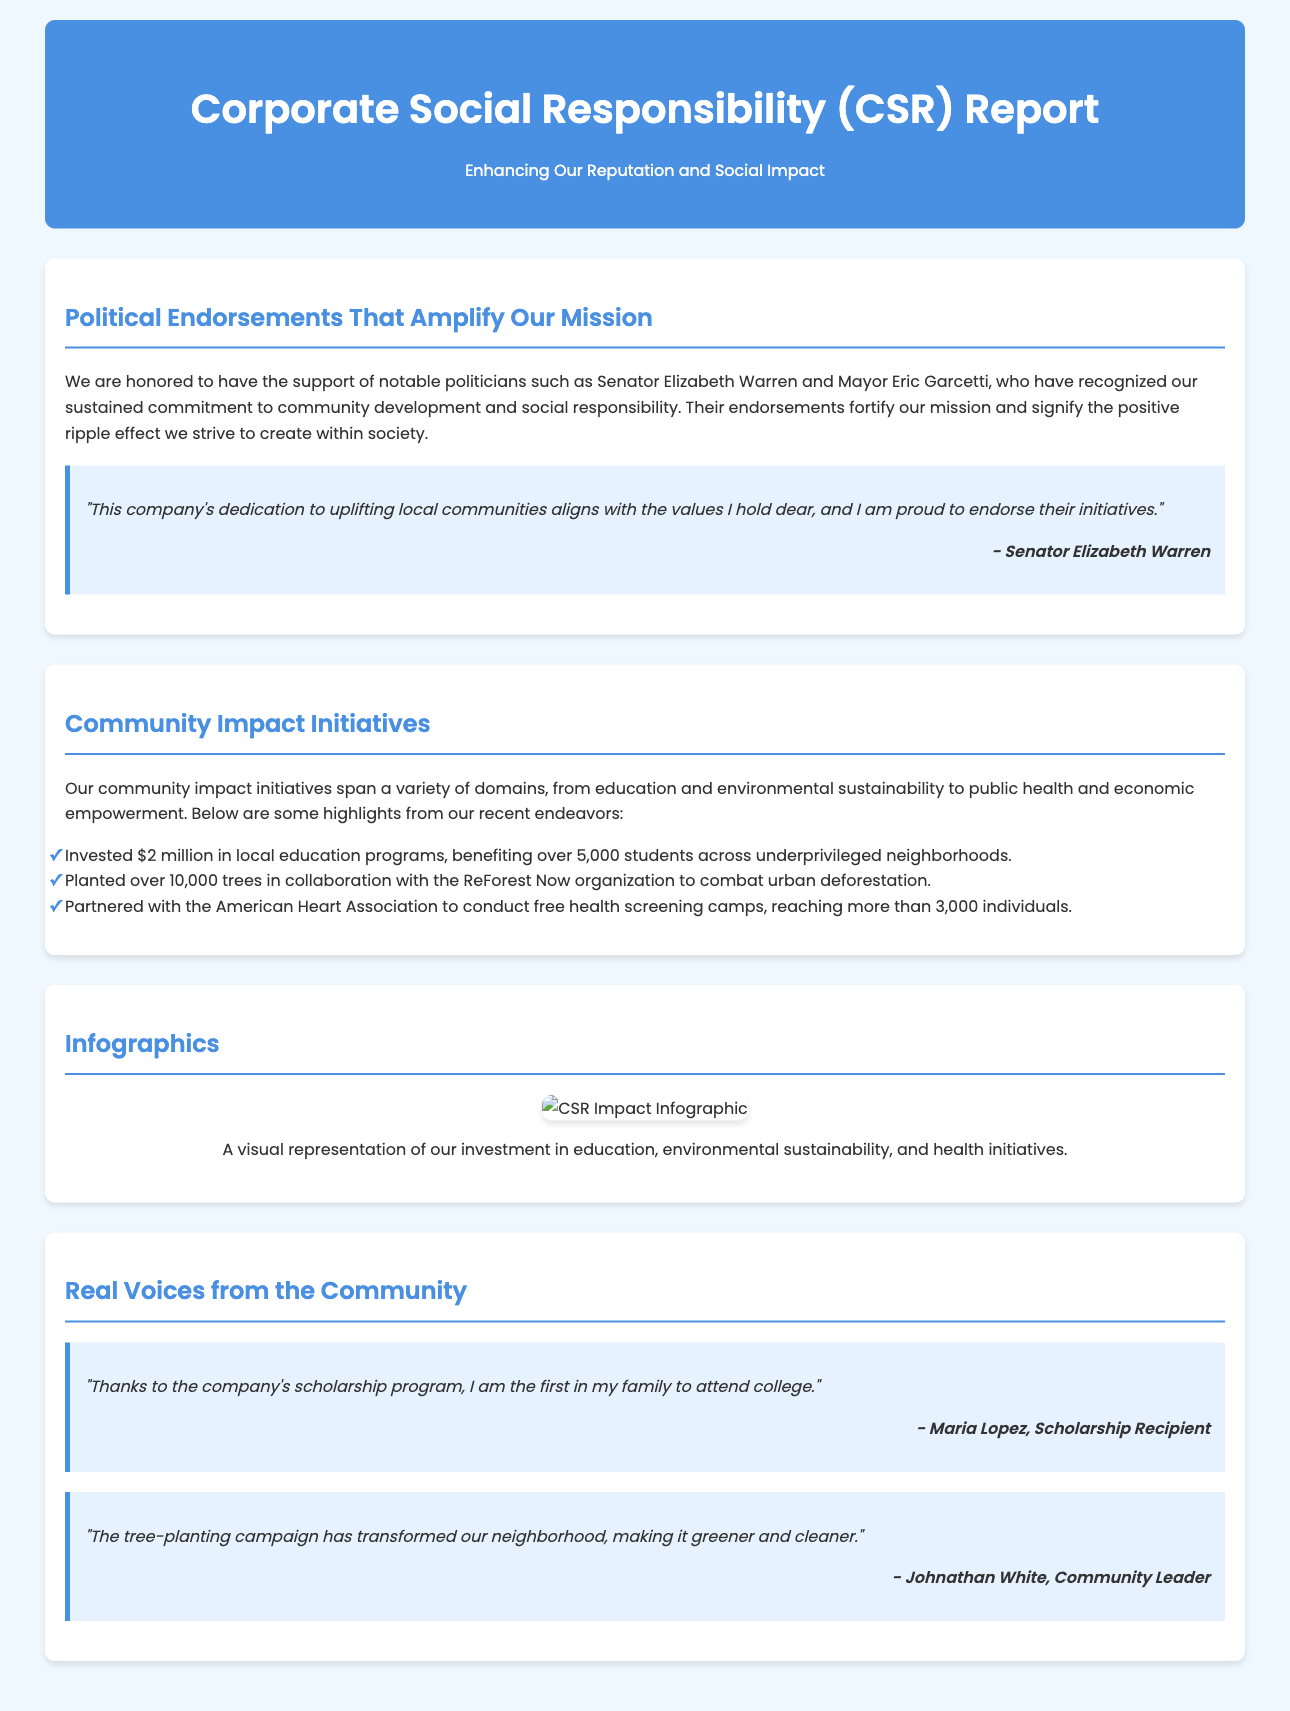What are the names of the politicians endorsing the company? The document lists Senator Elizabeth Warren and Mayor Eric Garcetti as the endorsing politicians.
Answer: Senator Elizabeth Warren and Mayor Eric Garcetti How much money was invested in local education programs? The document states that $2 million was invested in education programs.
Answer: $2 million How many trees were planted as part of the initiative? According to the document, over 10,000 trees were planted in collaboration with ReForest Now.
Answer: Over 10,000 trees What was the primary focus of the partnerships with the American Heart Association? The document indicates that free health screening camps were conducted in partnership with the American Heart Association.
Answer: Free health screening camps Who expressed pride in endorsing the company's initiatives? The document includes a quote from Senator Elizabeth Warren expressing pride in endorsing the company's initiatives.
Answer: Senator Elizabeth Warren What was one outcome mentioned from the scholarship program? The document states that one student is the first in their family to attend college due to the scholarship program.
Answer: First in family to attend college What is the title of the infographic depicting community investment? The document includes an infographic showing the impact of the company's community investment initiatives.
Answer: CSR Impact Infographic What type of community leader commented on the tree-planting campaign? The document features a community leader named Johnathan White commenting on the tree-planting campaign.
Answer: Johnathan White What is the color theme used in the document's header? The header background color of the document is blue, specifically #4a90e2.
Answer: Blue 